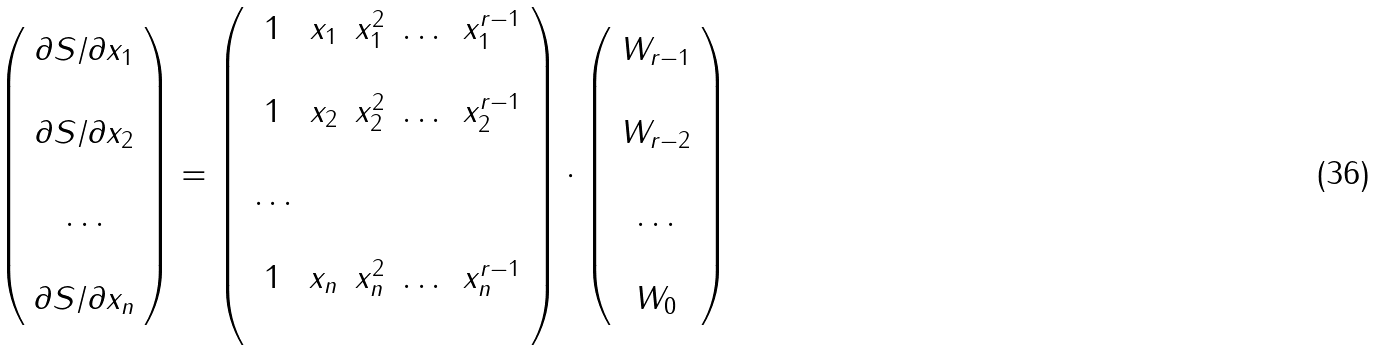Convert formula to latex. <formula><loc_0><loc_0><loc_500><loc_500>\left ( \begin{array} { c c c c } \partial S / \partial x _ { 1 } \\ \\ \partial S / \partial x _ { 2 } \\ \\ \dots \\ \\ \partial S / \partial x _ { n } \\ \end{array} \right ) = \left ( \begin{array} { c c c c c c c } 1 & x _ { 1 } & x _ { 1 } ^ { 2 } & \dots & x _ { 1 } ^ { r - 1 } \\ \\ 1 & x _ { 2 } & x _ { 2 } ^ { 2 } & \dots & x _ { 2 } ^ { r - 1 } \\ \\ \dots \\ \\ 1 & x _ { n } & x _ { n } ^ { 2 } & \dots & x _ { n } ^ { r - 1 } \\ \\ \end{array} \right ) \cdot \left ( \begin{array} { c c c c } W _ { r - 1 } \\ \\ W _ { r - 2 } \\ \\ \dots \\ \\ W _ { 0 } \\ \end{array} \right )</formula> 